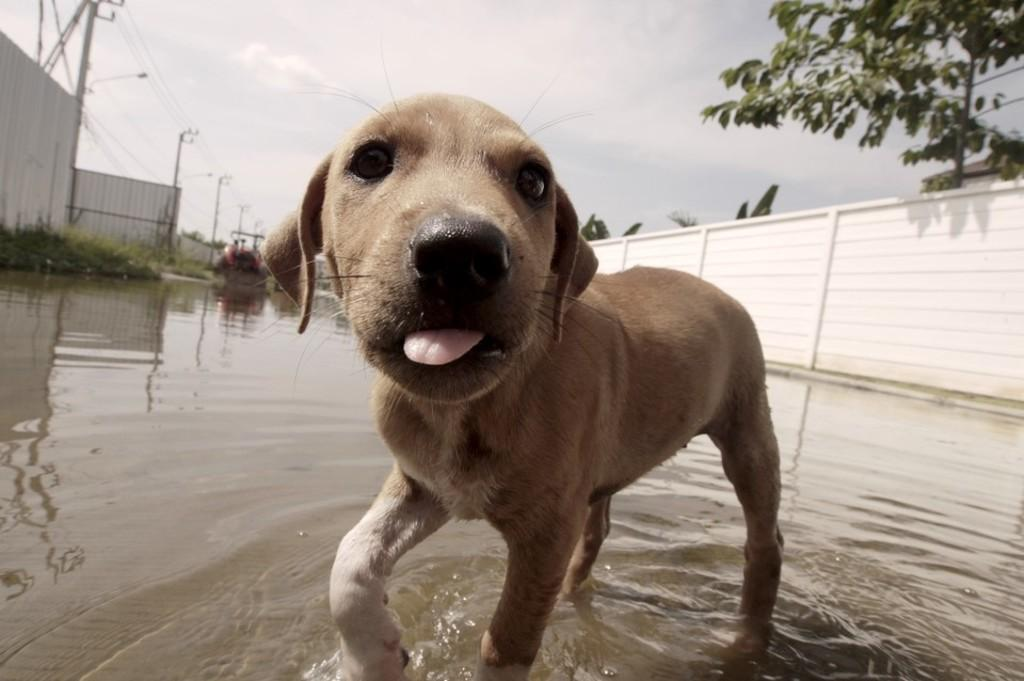What type of animal can be seen in the image? There is a dog in the image. What is the primary element visible in the image? Water is visible in the image. What type of man-made structure is present in the image? There is a street lamp in the image. What type of infrastructure is present in the image? Current poles are present in the image. What type of vegetation is visible in the image? There is a tree in the image. What is visible at the top of the image? The sky is visible at the top of the image. How many hens can be seen laying eggs in the image? There are no hens laying eggs in the image. 